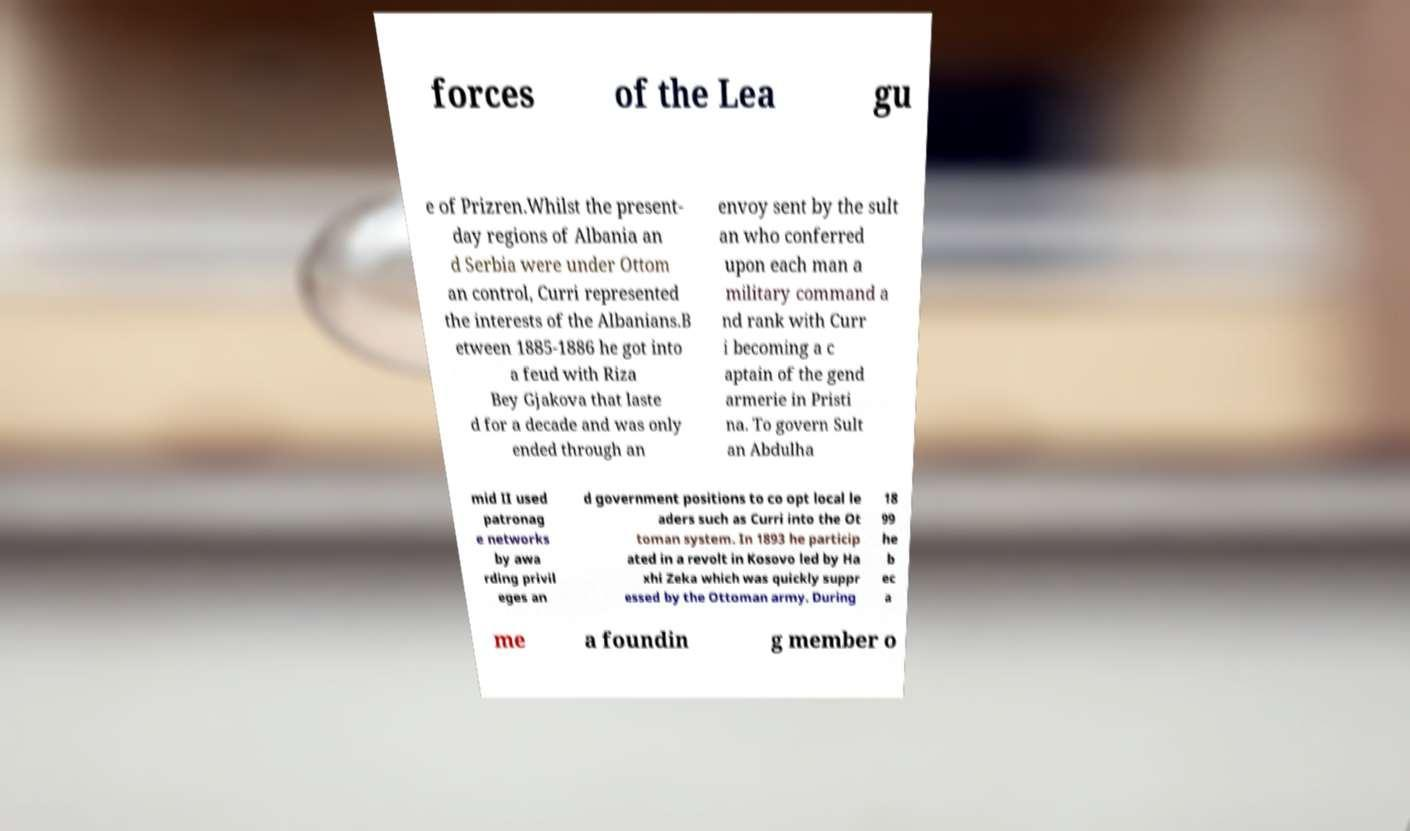Can you read and provide the text displayed in the image?This photo seems to have some interesting text. Can you extract and type it out for me? forces of the Lea gu e of Prizren.Whilst the present- day regions of Albania an d Serbia were under Ottom an control, Curri represented the interests of the Albanians.B etween 1885-1886 he got into a feud with Riza Bey Gjakova that laste d for a decade and was only ended through an envoy sent by the sult an who conferred upon each man a military command a nd rank with Curr i becoming a c aptain of the gend armerie in Pristi na. To govern Sult an Abdulha mid II used patronag e networks by awa rding privil eges an d government positions to co opt local le aders such as Curri into the Ot toman system. In 1893 he particip ated in a revolt in Kosovo led by Ha xhi Zeka which was quickly suppr essed by the Ottoman army. During 18 99 he b ec a me a foundin g member o 